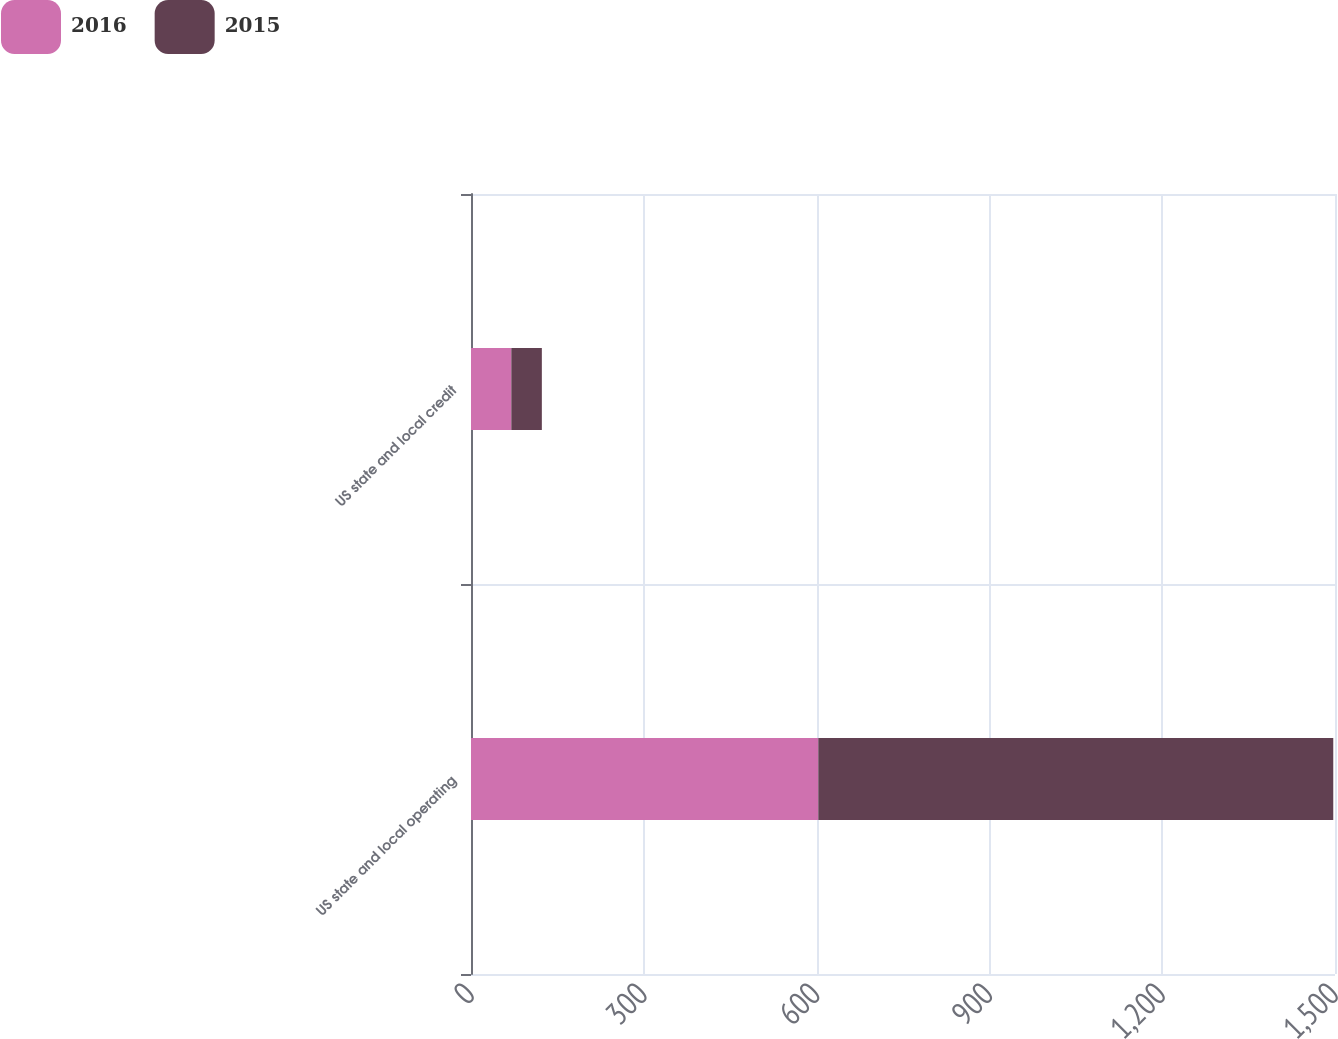Convert chart. <chart><loc_0><loc_0><loc_500><loc_500><stacked_bar_chart><ecel><fcel>US state and local operating<fcel>US state and local credit<nl><fcel>2016<fcel>603<fcel>70<nl><fcel>2015<fcel>894<fcel>53<nl></chart> 